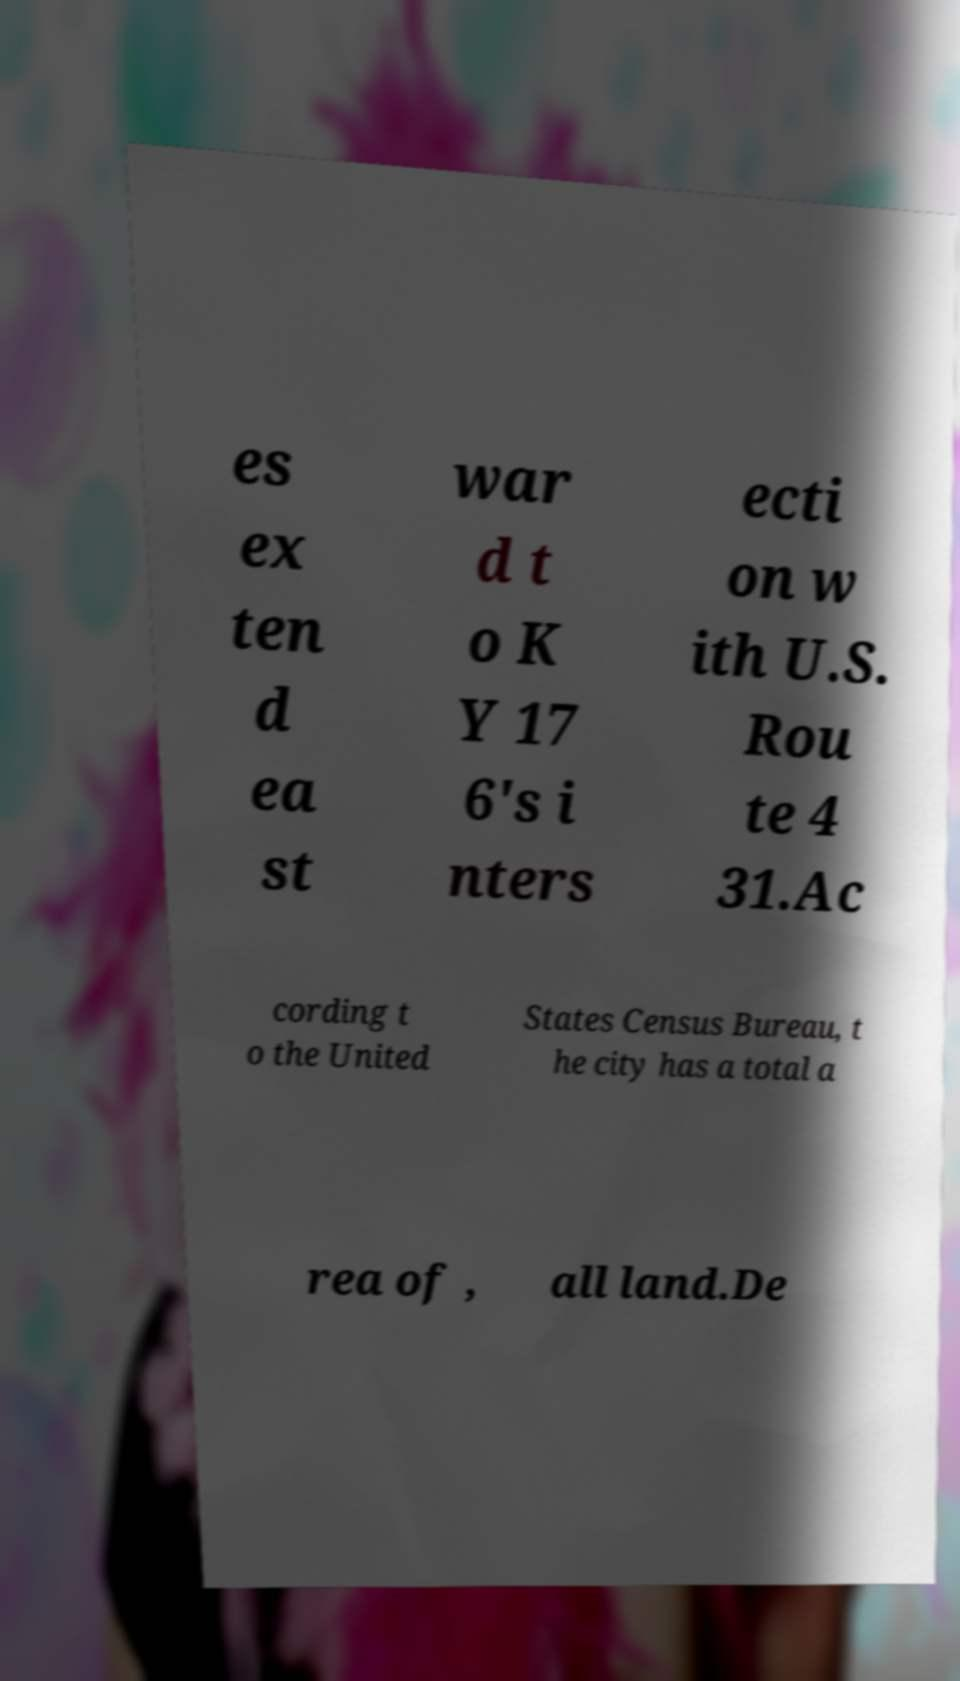For documentation purposes, I need the text within this image transcribed. Could you provide that? es ex ten d ea st war d t o K Y 17 6's i nters ecti on w ith U.S. Rou te 4 31.Ac cording t o the United States Census Bureau, t he city has a total a rea of , all land.De 